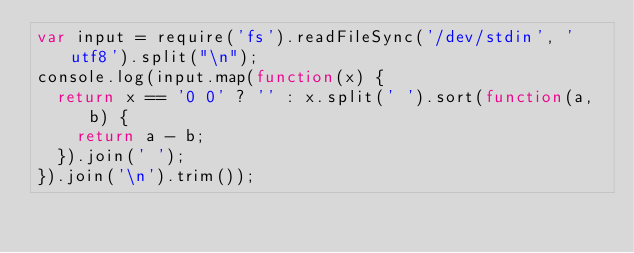Convert code to text. <code><loc_0><loc_0><loc_500><loc_500><_JavaScript_>var input = require('fs').readFileSync('/dev/stdin', 'utf8').split("\n");
console.log(input.map(function(x) {
  return x == '0 0' ? '' : x.split(' ').sort(function(a, b) {
    return a - b;
  }).join(' ');
}).join('\n').trim());</code> 